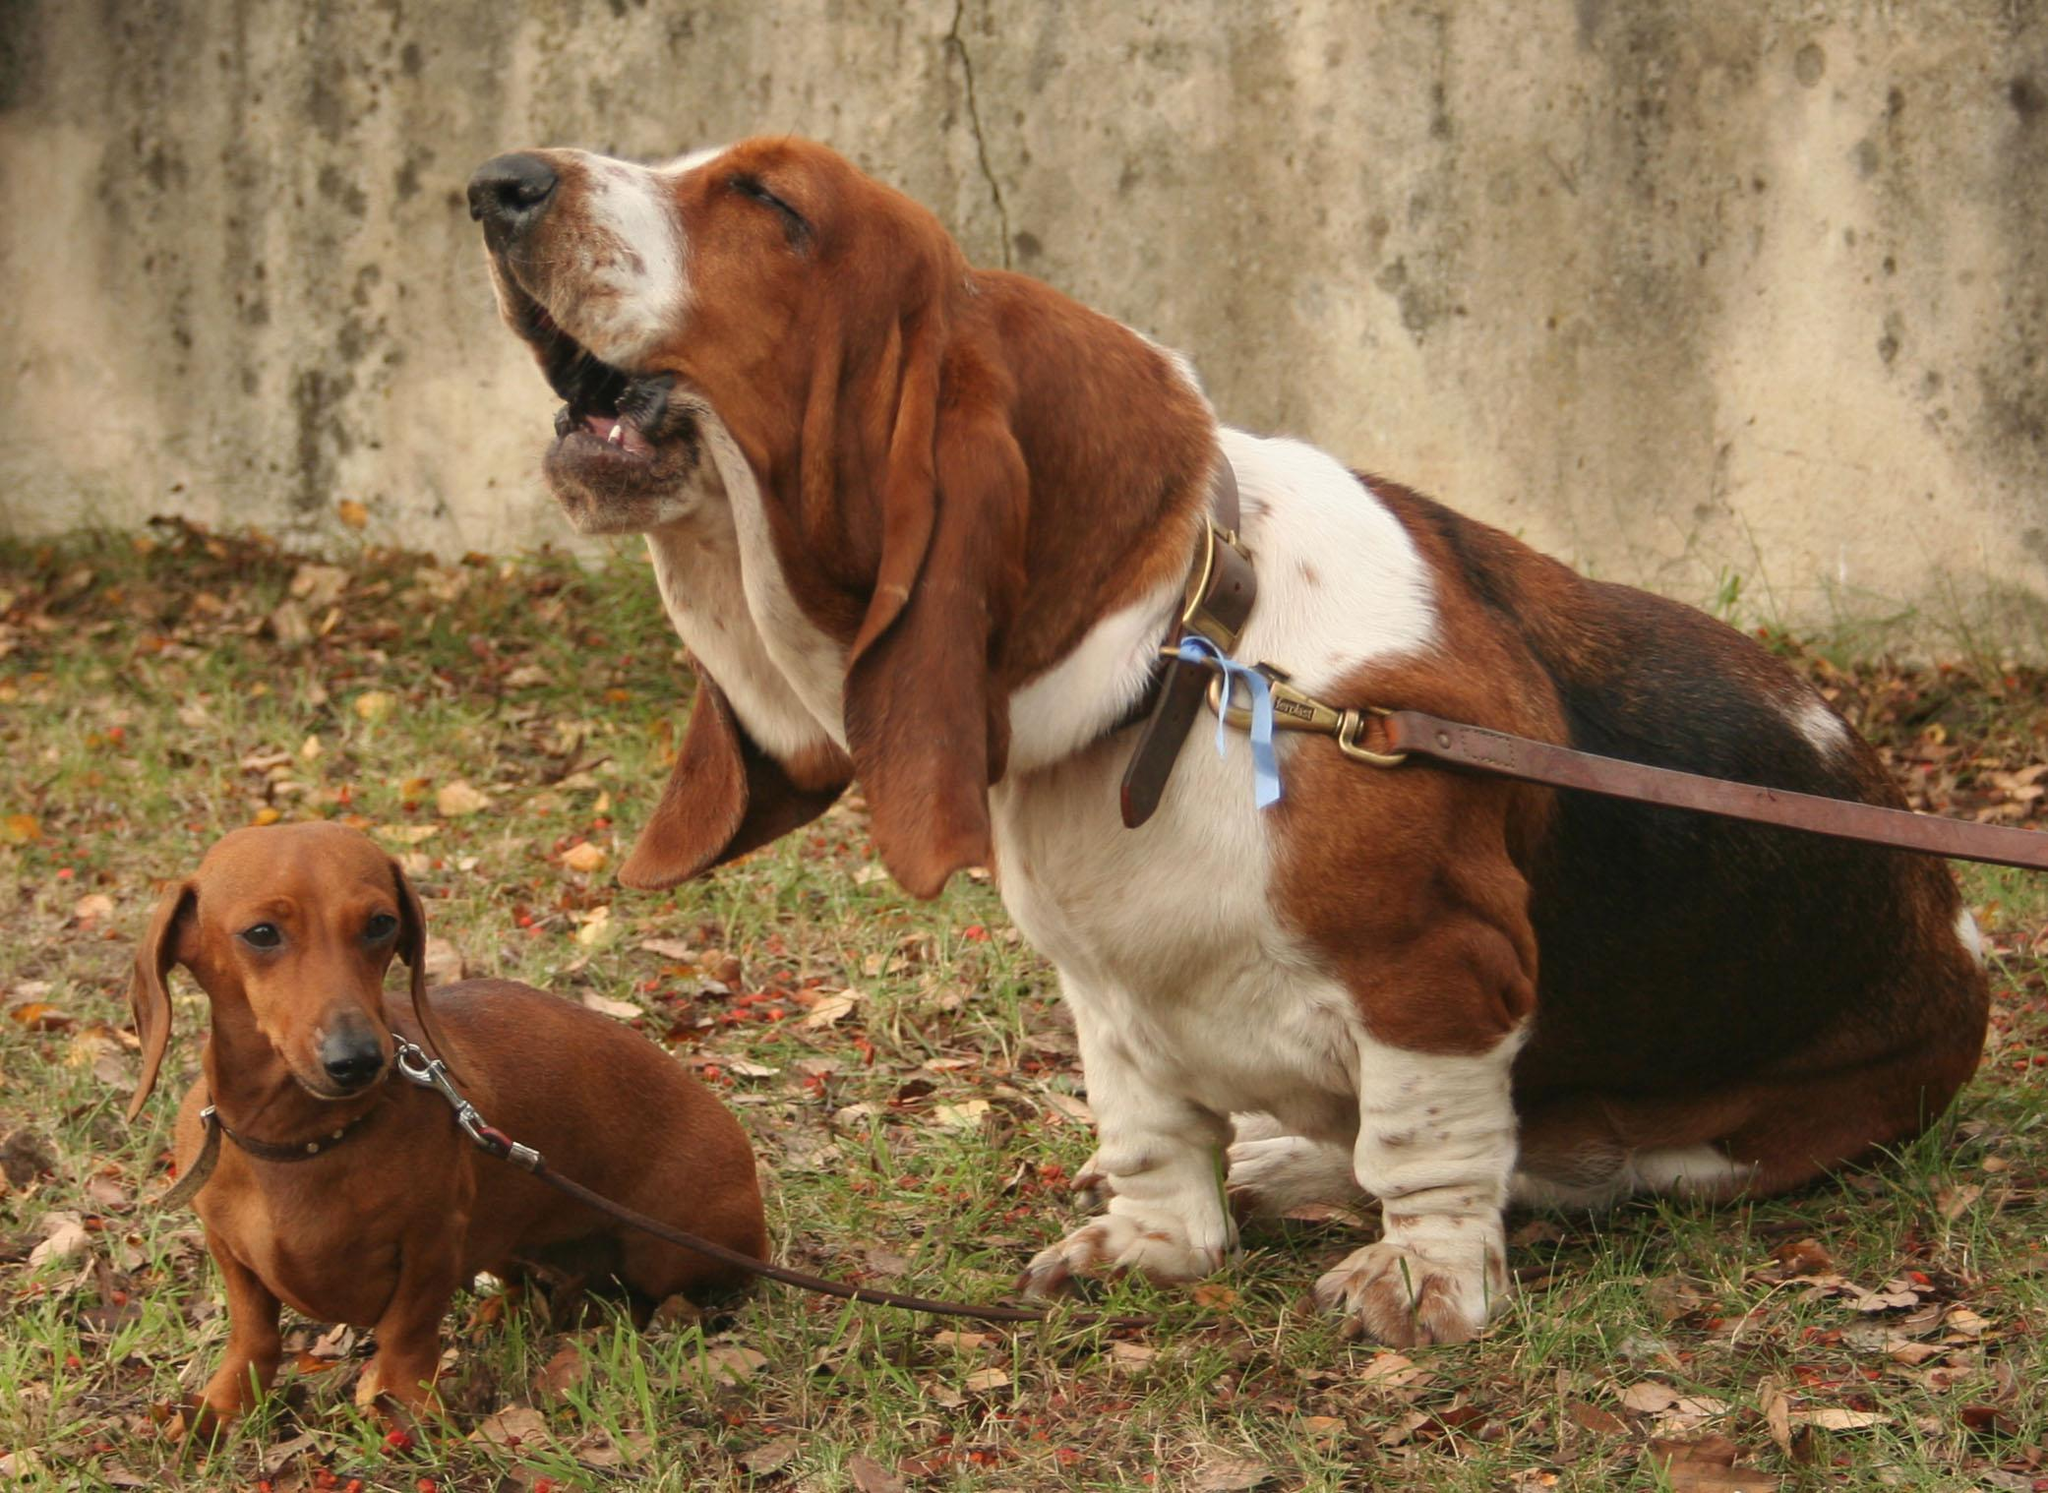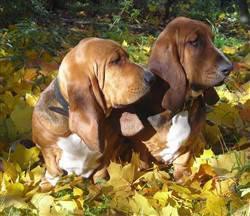The first image is the image on the left, the second image is the image on the right. Evaluate the accuracy of this statement regarding the images: "There are at most two dogs.". Is it true? Answer yes or no. No. The first image is the image on the left, the second image is the image on the right. Analyze the images presented: Is the assertion "There is atleast one dog present that is not a bloodhound." valid? Answer yes or no. Yes. 